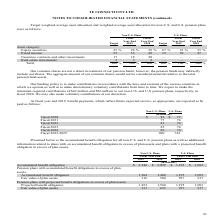According to Te Connectivity's financial document, What is the company's funding policy? to make contributions in accordance with the laws and customs of the various countries in which we operate as well as to make discretionary voluntary contributions from time to time. The document states: "Our funding policy is to make contributions in accordance with the laws and customs of the various countries in which we operate as well as to make di..." Also, How much minimum required contributions is expected to be made to the non-U.S. pension plan? According to the financial document, $42 million. The relevant text states: "pect to make the minimum required contributions of $42 million and $26 million to our non-U.S. and U.S. pension plans, respectively, in fiscal 2020. We may also ma..." Also, Which are the periods for which benefit payments are expected to be paid? The document contains multiple relevant values: Fiscal 2020, Fiscal 2021, Fiscal 2022, Fiscal 2023, Fiscal 2024, Fiscal 2025-2029. From the document: "Fiscal 2021 77 74 Fiscal 2025-2029 490 361 Fiscal 2023 85 74 Fiscal 2020 $ 82 $ 77 Fiscal 2024 86 74 Fiscal 2022 81 74..." Additionally, In which Fiscal year from 2020 to 2024 would the benefit payments under the U.S Plans be the largest? According to the financial document, Fiscal 2020. The relevant text states: "Fiscal 2020 $ 82 $ 77..." Also, can you calculate: What is the change in Non-U.S. benefit payments expected to be paid in Fiscal 2023 from Fiscal 2022? Based on the calculation: 85-81, the result is 4 (in millions). This is based on the information: "Fiscal 2022 81 74 Fiscal 2023 85 74..." The key data points involved are: 81, 85. Also, can you calculate: What is the percentage change in Non-U.S. benefit payments expected to be paid in Fiscal 2023 from Fiscal 2022? To answer this question, I need to perform calculations using the financial data. The calculation is: (85-81)/81, which equals 4.94 (percentage). This is based on the information: "Fiscal 2022 81 74 Fiscal 2023 85 74..." The key data points involved are: 81, 85. 